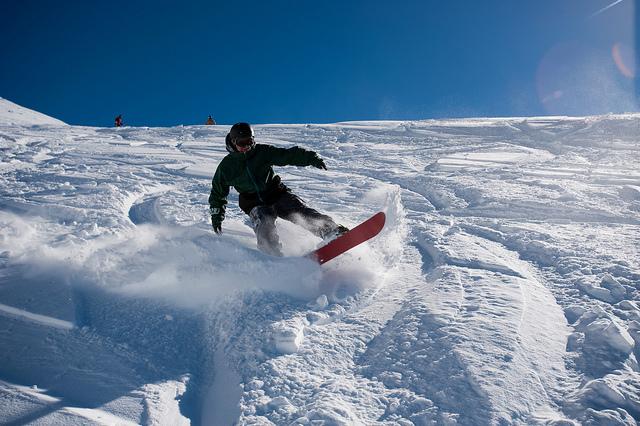What color is the snowboard?
Write a very short answer. Red. Is this a rocky terrain?
Answer briefly. No. What color are their coats?
Keep it brief. Black. What is the person doing?
Quick response, please. Snowboarding. What color is the jacket?
Concise answer only. Black. 